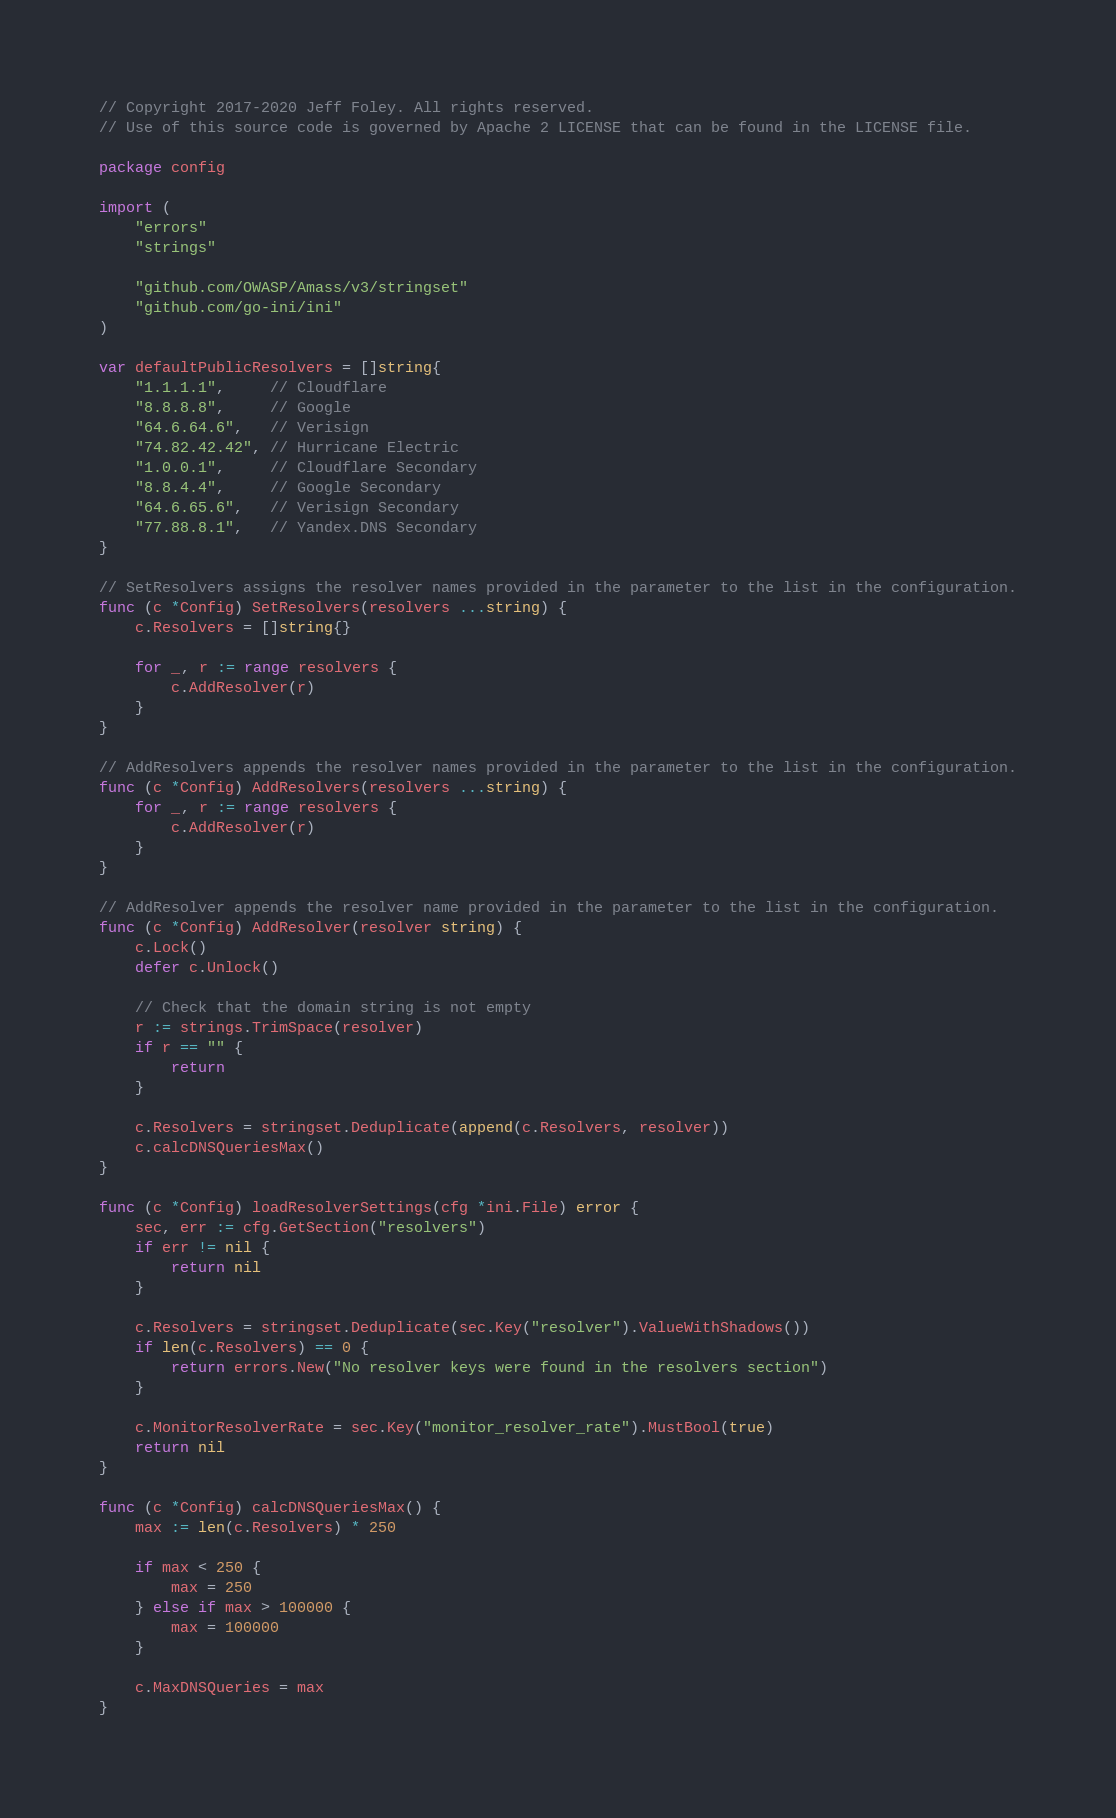<code> <loc_0><loc_0><loc_500><loc_500><_Go_>// Copyright 2017-2020 Jeff Foley. All rights reserved.
// Use of this source code is governed by Apache 2 LICENSE that can be found in the LICENSE file.

package config

import (
	"errors"
	"strings"

	"github.com/OWASP/Amass/v3/stringset"
	"github.com/go-ini/ini"
)

var defaultPublicResolvers = []string{
	"1.1.1.1",     // Cloudflare
	"8.8.8.8",     // Google
	"64.6.64.6",   // Verisign
	"74.82.42.42", // Hurricane Electric
	"1.0.0.1",     // Cloudflare Secondary
	"8.8.4.4",     // Google Secondary
	"64.6.65.6",   // Verisign Secondary
	"77.88.8.1",   // Yandex.DNS Secondary
}

// SetResolvers assigns the resolver names provided in the parameter to the list in the configuration.
func (c *Config) SetResolvers(resolvers ...string) {
	c.Resolvers = []string{}

	for _, r := range resolvers {
		c.AddResolver(r)
	}
}

// AddResolvers appends the resolver names provided in the parameter to the list in the configuration.
func (c *Config) AddResolvers(resolvers ...string) {
	for _, r := range resolvers {
		c.AddResolver(r)
	}
}

// AddResolver appends the resolver name provided in the parameter to the list in the configuration.
func (c *Config) AddResolver(resolver string) {
	c.Lock()
	defer c.Unlock()

	// Check that the domain string is not empty
	r := strings.TrimSpace(resolver)
	if r == "" {
		return
	}

	c.Resolvers = stringset.Deduplicate(append(c.Resolvers, resolver))
	c.calcDNSQueriesMax()
}

func (c *Config) loadResolverSettings(cfg *ini.File) error {
	sec, err := cfg.GetSection("resolvers")
	if err != nil {
		return nil
	}

	c.Resolvers = stringset.Deduplicate(sec.Key("resolver").ValueWithShadows())
	if len(c.Resolvers) == 0 {
		return errors.New("No resolver keys were found in the resolvers section")
	}

	c.MonitorResolverRate = sec.Key("monitor_resolver_rate").MustBool(true)
	return nil
}

func (c *Config) calcDNSQueriesMax() {
	max := len(c.Resolvers) * 250

	if max < 250 {
		max = 250
	} else if max > 100000 {
		max = 100000
	}

	c.MaxDNSQueries = max
}
</code> 